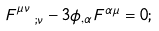Convert formula to latex. <formula><loc_0><loc_0><loc_500><loc_500>F ^ { \mu \nu } _ { \ \ ; \nu } - 3 \phi _ { , \alpha } F ^ { \alpha \mu } = 0 ;</formula> 